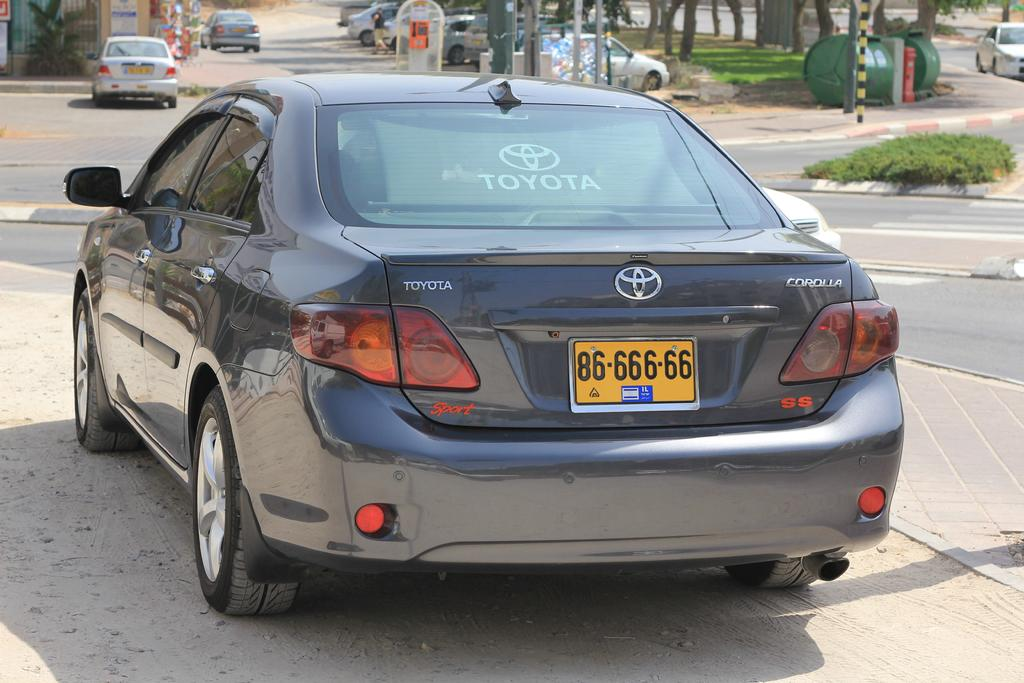<image>
Summarize the visual content of the image. The back of a black toyota corola with a black and yellow license plate. 